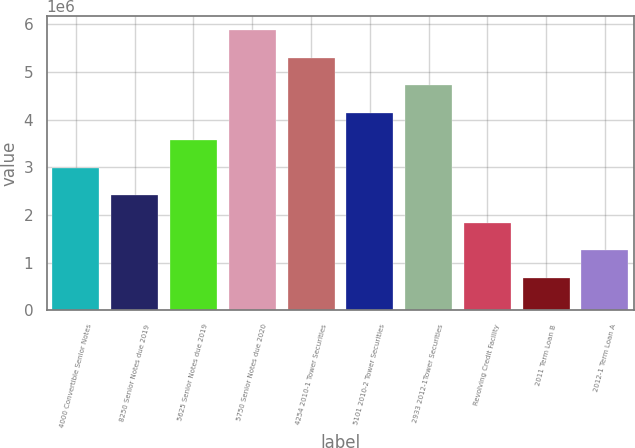Convert chart to OTSL. <chart><loc_0><loc_0><loc_500><loc_500><bar_chart><fcel>4000 Convertible Senior Notes<fcel>8250 Senior Notes due 2019<fcel>5625 Senior Notes due 2019<fcel>5750 Senior Notes due 2020<fcel>4254 2010-1 Tower Securities<fcel>5101 2010-2 Tower Securities<fcel>2933 2012-1Tower Securities<fcel>Revolving Credit Facility<fcel>2011 Term Loan B<fcel>2012-1 Term Loan A<nl><fcel>2.99318e+06<fcel>2.41649e+06<fcel>3.56986e+06<fcel>5.87661e+06<fcel>5.29992e+06<fcel>4.14655e+06<fcel>4.72323e+06<fcel>1.8398e+06<fcel>686431<fcel>1.26312e+06<nl></chart> 